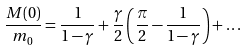Convert formula to latex. <formula><loc_0><loc_0><loc_500><loc_500>\frac { M ( 0 ) } { m _ { 0 } } = \frac { 1 } { 1 - \gamma } + \frac { \gamma } { 2 } \left ( \frac { \pi } { 2 } - \frac { 1 } { 1 - \gamma } \right ) + \dots</formula> 